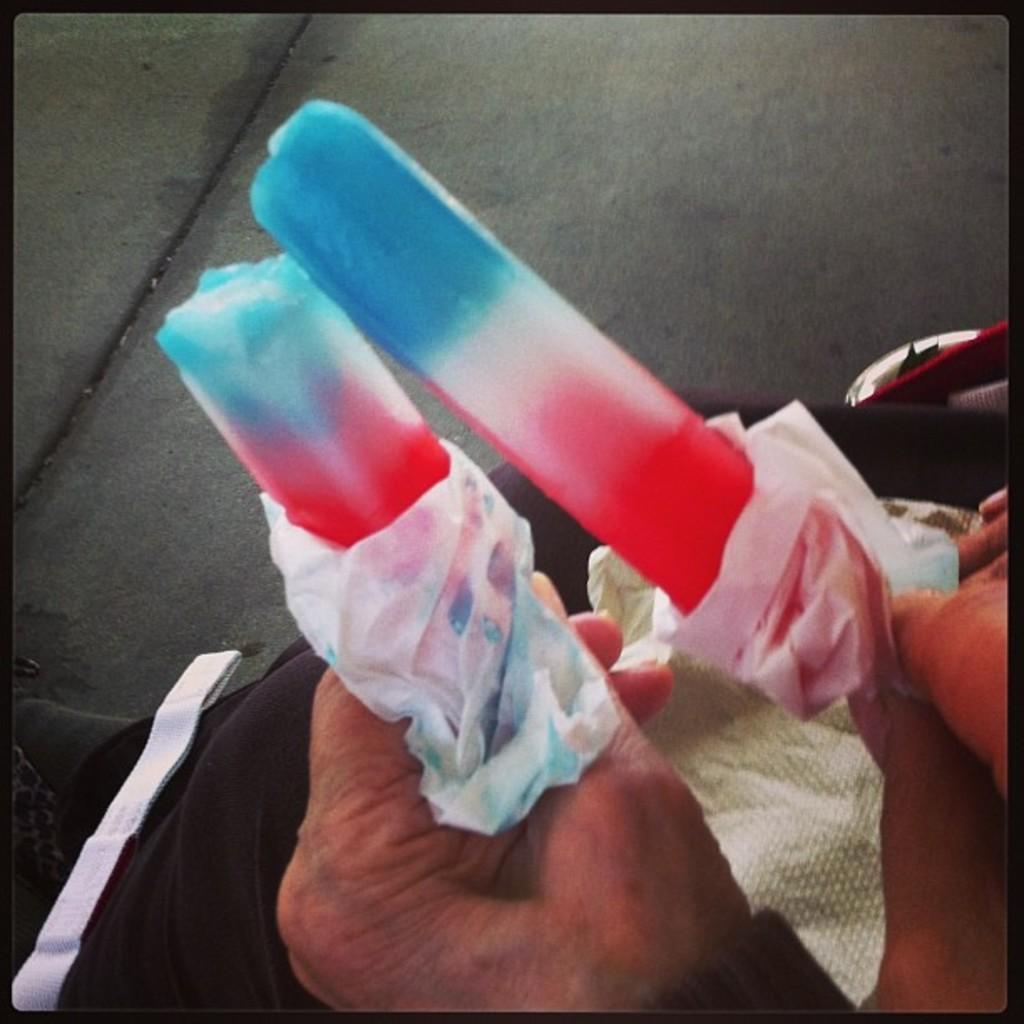How would you summarize this image in a sentence or two? In this image we can see the hands of a person holding the multi colored ice creams. 